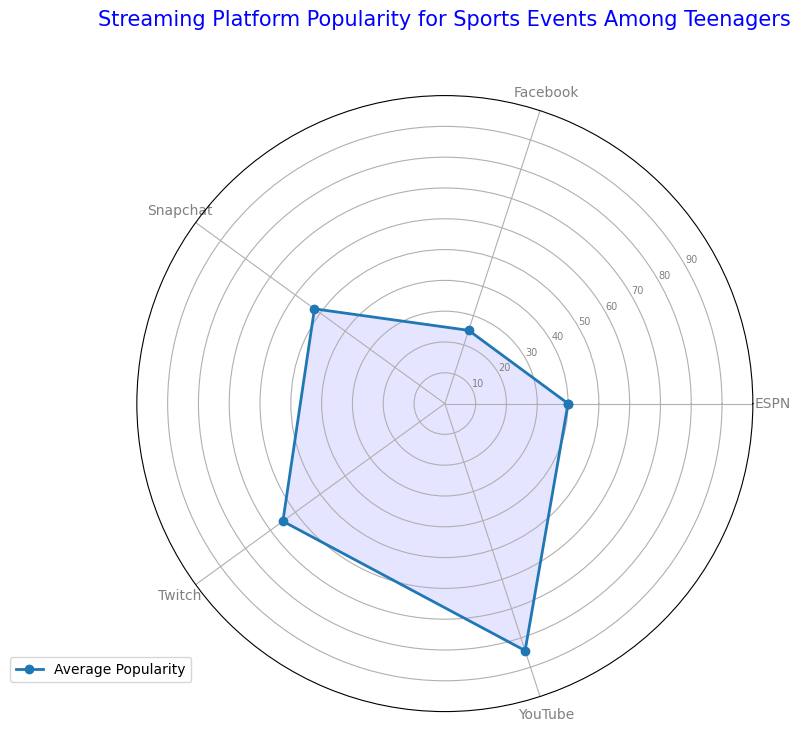what is the average popularity of YouTube? The first step is to identify the popularity values for YouTube: 85, 80, and 88. Sum these values (85 + 80 + 88 = 253) and then divide by the number of values (3). This results in 253 / 3 = 84.33.
Answer: 84.33 Which platform has the highest average popularity? By looking at the radar chart, identify the platform with the largest radius value. YouTube has the highest point on the radar chart.
Answer: YouTube Which platform has the lowest average popularity? By looking at the radar chart, identify the platform with the smallest radius value. Facebook has the lowest point on the radar chart.
Answer: Facebook How does the average popularity of Snapchat compare to ESPN? Measure the respective radius values for Snapchat and ESPN on the radar chart and compare them. Snapchat's average popularity is 52.33 and ESPN's is 40.
Answer: Snapchat is more popular What is the difference in average popularity between YouTube and Facebook? Identify the average popularities for YouTube (84.33) and Facebook (25), then subtract the Facebook value from the YouTube value: 84.33 - 25 = 59.33.
Answer: 59.33 What does the overall shape of the radar chart suggest about platform popularity? The radar chart shows peaks and troughs. A high peak at YouTube and much lower points for Facebook and ESPN suggest a wide range of popularity among the platforms.
Answer: Wide range in popularity Which two platforms are the closest in average popularity? On the radar chart, the two lines closest to each other would represent the answer. Twitch (65) and Snapchat (52.33) are close.
Answer: Twitch and Snapchat Is there any platform that is equally or almost equally popular to two other platforms? By examining the radar chart, find a point that has approximately equal distance between two others. This does not appear to be the case as each platform's popularity varies.
Answer: No Are there more platforms above or below the average popularity value for all platforms? Add all the average popularities (84.33 + 65 + 40 + 25 + 52.33 = 266.66) and divide by 5 for the average (53.33). Compare how many platforms are above or below this average. YouTube, Twitch, and Snapchat are above, while ESPN and Facebook are below.
Answer: More are above Which platform's popularity has the maximum variation, and what does this imply? Visually analyze the radar chart for the platform with the most significant spread between measurements. Facebook with a range from 20 to 30 has low variation, YouTube with 80-88 has less variation indicating consistent popularity. ESPN ranges from 35-45. Therefore, Facebook's consistent low average suggests its overall lower popularity.
Answer: ESPN shows variation 